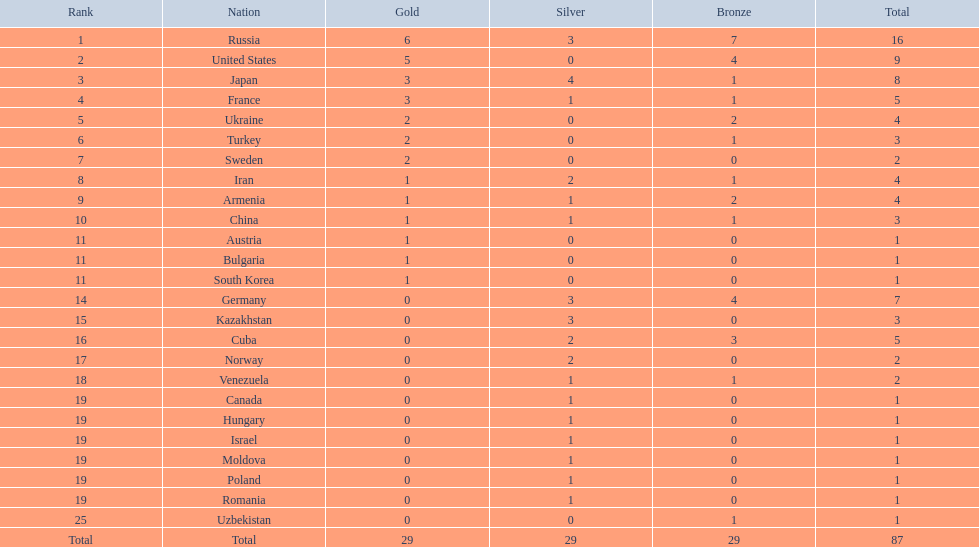Which nations only won less then 5 medals? Ukraine, Turkey, Sweden, Iran, Armenia, China, Austria, Bulgaria, South Korea, Germany, Kazakhstan, Norway, Venezuela, Canada, Hungary, Israel, Moldova, Poland, Romania, Uzbekistan. Which of these were not asian nations? Ukraine, Turkey, Sweden, Iran, Armenia, Austria, Bulgaria, Germany, Kazakhstan, Norway, Venezuela, Canada, Hungary, Israel, Moldova, Poland, Romania, Uzbekistan. Which of those did not win any silver medals? Ukraine, Turkey, Sweden, Austria, Bulgaria, Uzbekistan. Which ones of these had only one medal total? Austria, Bulgaria, Uzbekistan. Which of those would be listed first alphabetically? Austria. 